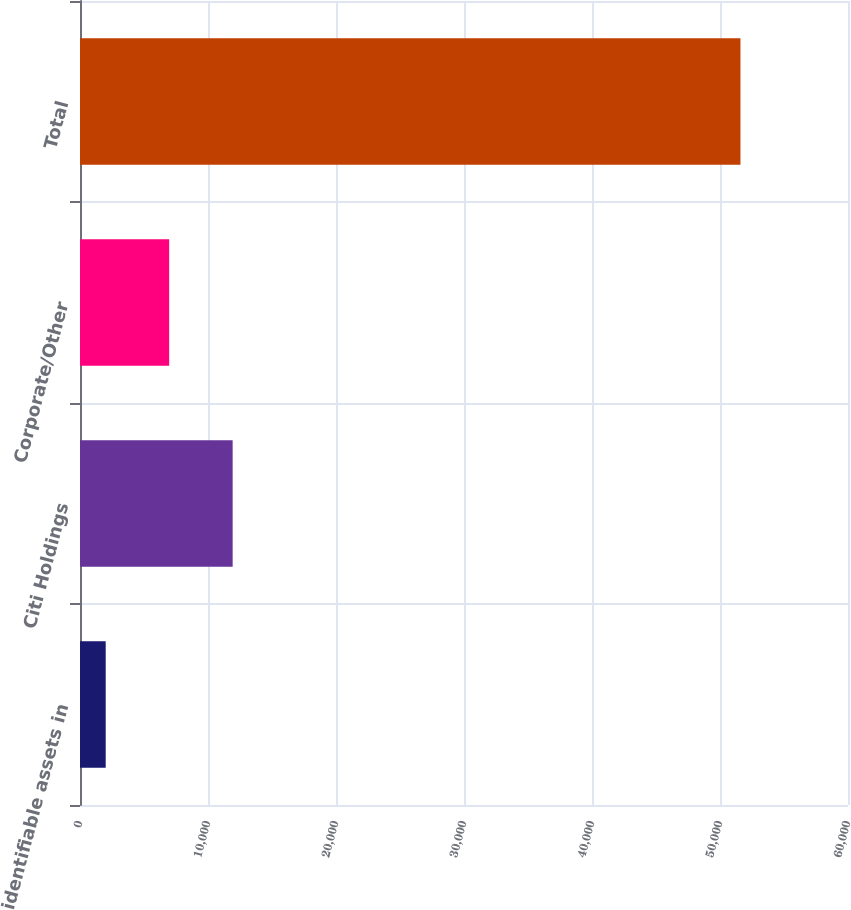Convert chart. <chart><loc_0><loc_0><loc_500><loc_500><bar_chart><fcel>identifiable assets in<fcel>Citi Holdings<fcel>Corporate/Other<fcel>Total<nl><fcel>2008<fcel>11926.2<fcel>6967.1<fcel>51599<nl></chart> 